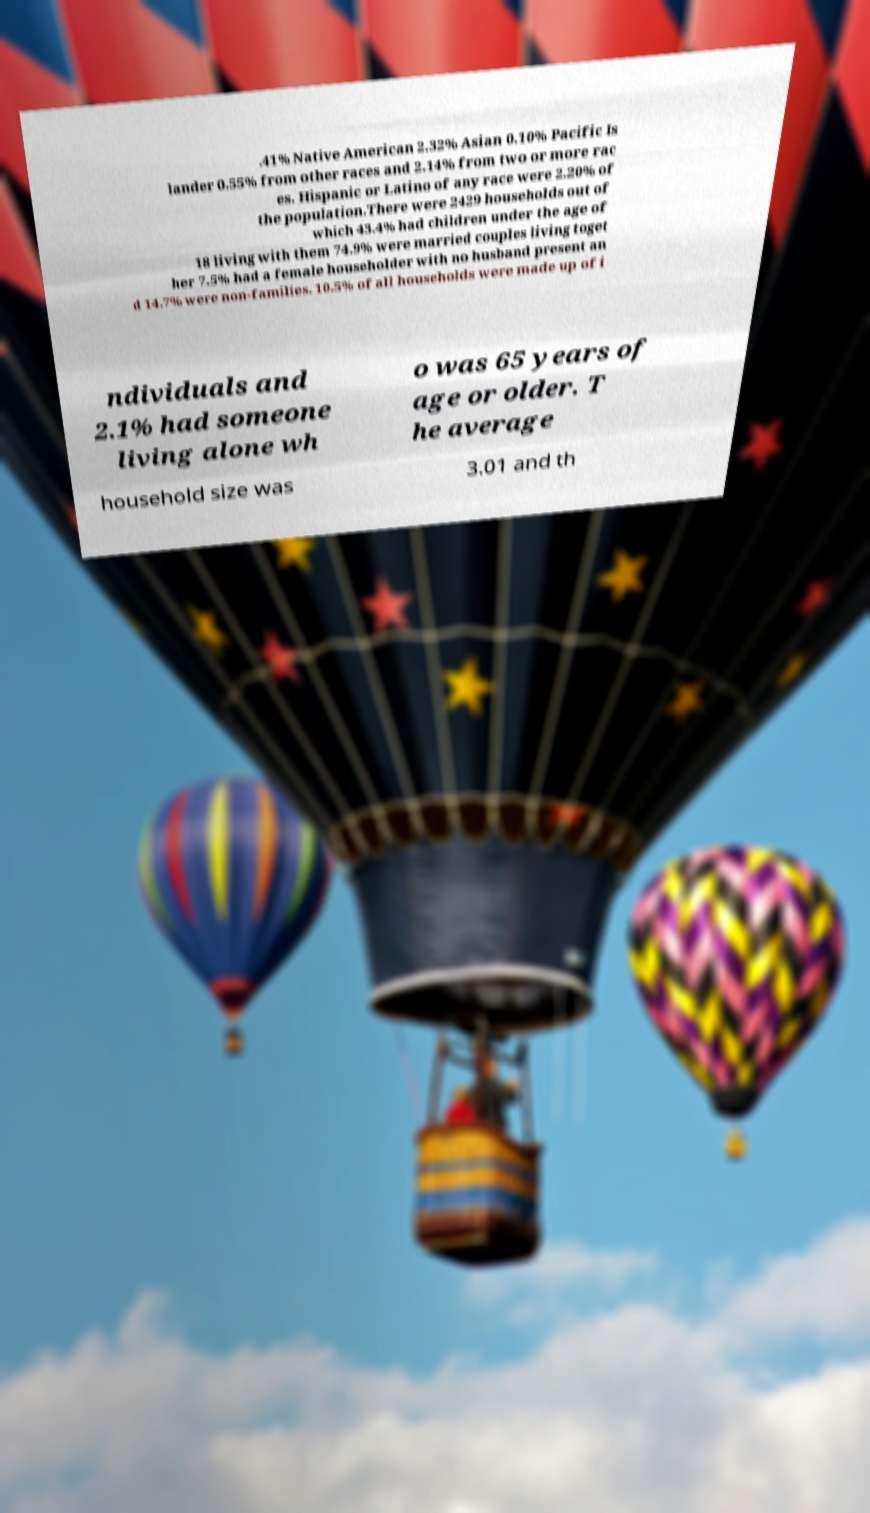Could you extract and type out the text from this image? .41% Native American 2.32% Asian 0.10% Pacific Is lander 0.55% from other races and 2.14% from two or more rac es. Hispanic or Latino of any race were 2.20% of the population.There were 2429 households out of which 43.4% had children under the age of 18 living with them 74.9% were married couples living toget her 7.5% had a female householder with no husband present an d 14.7% were non-families. 10.5% of all households were made up of i ndividuals and 2.1% had someone living alone wh o was 65 years of age or older. T he average household size was 3.01 and th 